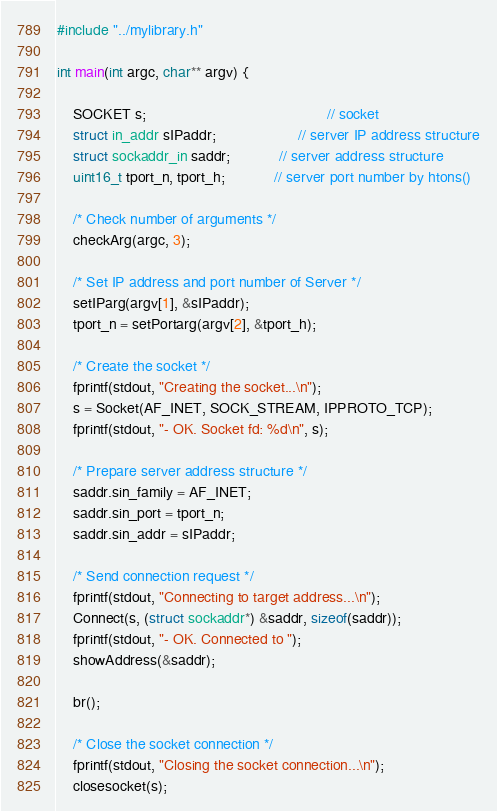<code> <loc_0><loc_0><loc_500><loc_500><_C_>#include "../mylibrary.h"

int main(int argc, char** argv) {

	SOCKET s; 											// socket
	struct in_addr sIPaddr;					// server IP address structure
	struct sockaddr_in saddr; 			// server address structure
	uint16_t tport_n, tport_h;			// server port number by htons()

	/* Check number of arguments */
	checkArg(argc, 3);
	
	/* Set IP address and port number of Server */
	setIParg(argv[1], &sIPaddr);
	tport_n = setPortarg(argv[2], &tport_h);

	/* Create the socket */
	fprintf(stdout, "Creating the socket...\n");
	s = Socket(AF_INET, SOCK_STREAM, IPPROTO_TCP);
	fprintf(stdout, "- OK. Socket fd: %d\n", s);
	
	/* Prepare server address structure */
	saddr.sin_family = AF_INET;
	saddr.sin_port = tport_n;
	saddr.sin_addr = sIPaddr;

	/* Send connection request */
	fprintf(stdout, "Connecting to target address...\n");
	Connect(s, (struct sockaddr*) &saddr, sizeof(saddr));
	fprintf(stdout, "- OK. Connected to ");
	showAddress(&saddr);
	
	br();
	
	/* Close the socket connection */
	fprintf(stdout, "Closing the socket connection...\n");
	closesocket(s);</code> 